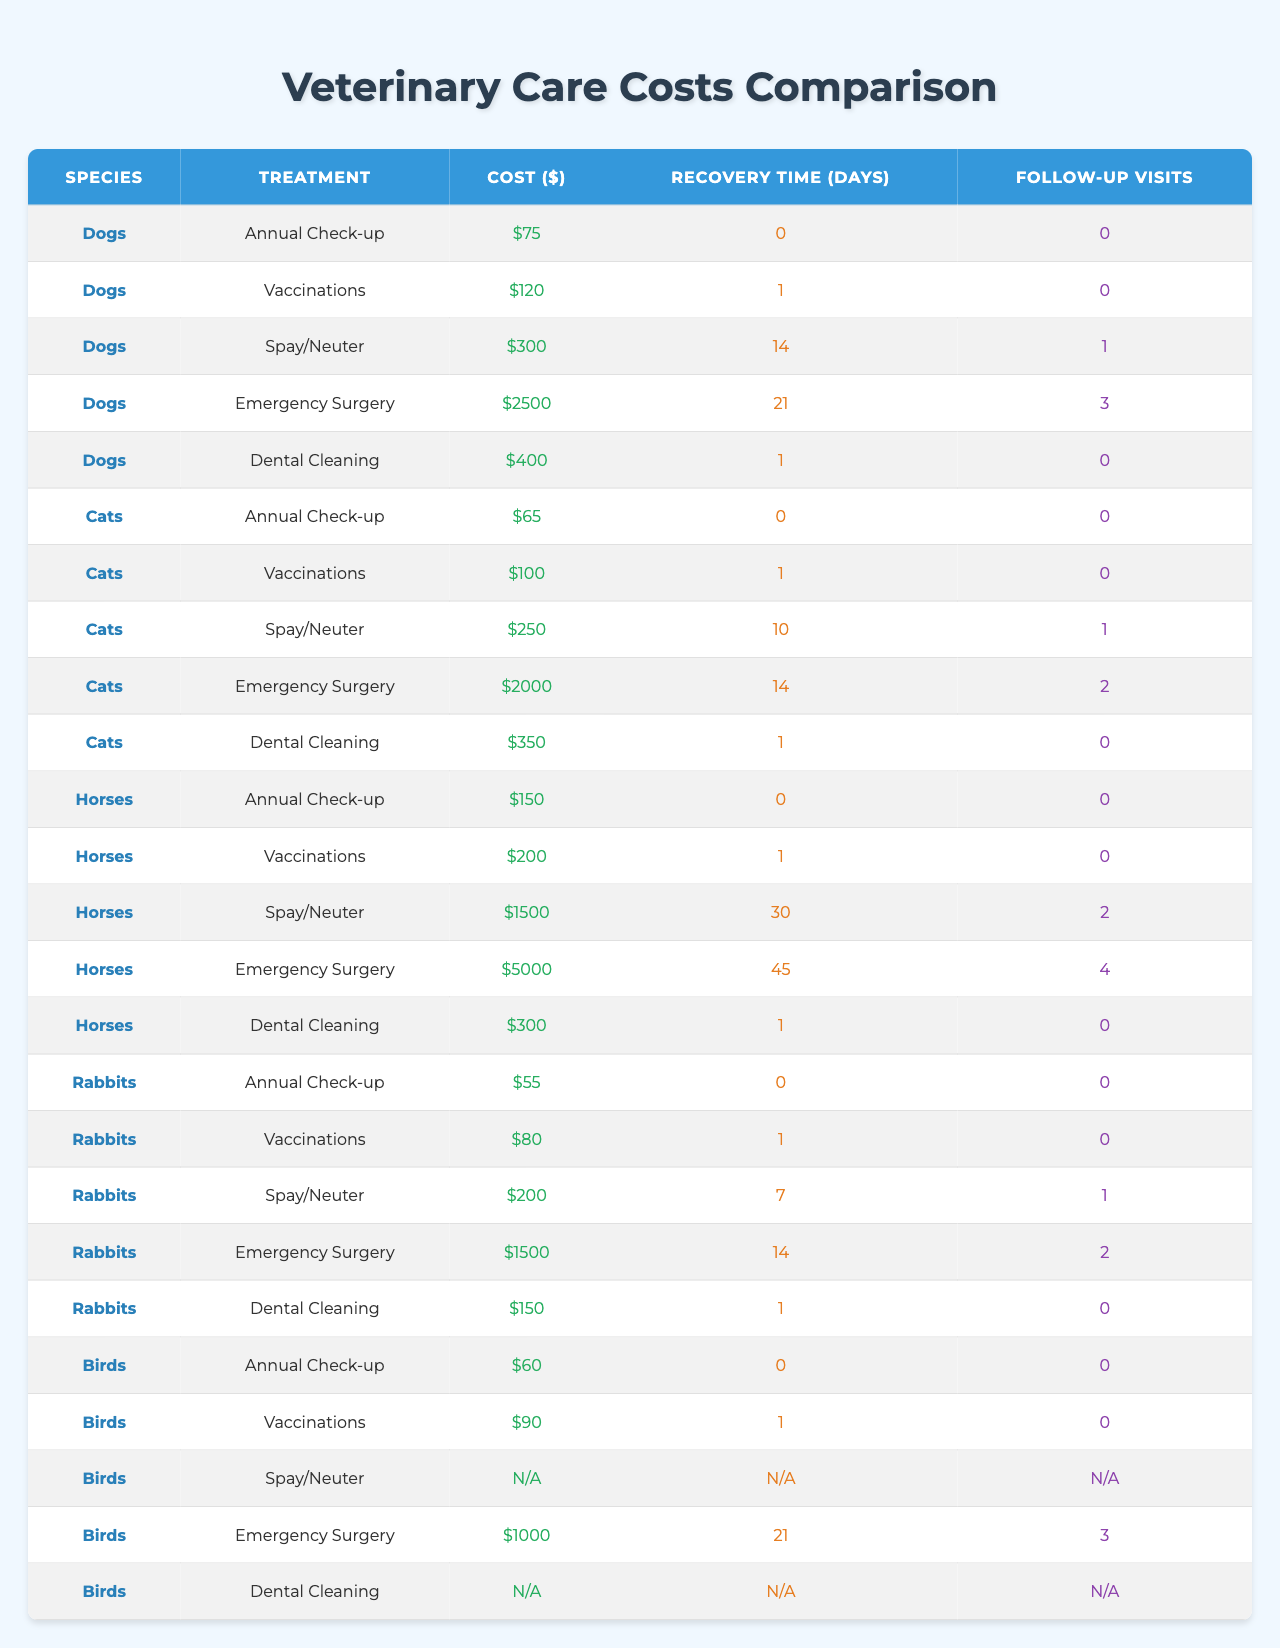What is the cost of an Annual Check-up for dogs? The table lists the cost of an Annual Check-up for dogs as $75 under the "Cost ($)" column.
Answer: $75 What treatment for cats has the highest cost? By examining the "Cost ($)" column for cats, the highest cost is for Spay/Neuter, which is $250.
Answer: Spay/Neuter Is the cost of Emergency Surgery for horses higher than for dogs? The cost for Emergency Surgery for horses is $5000, while for dogs, it is $2500. Since $5000 is greater than $2500, the statement is true.
Answer: Yes What is the average recovery time for dental cleaning for rabbits? The table indicates that the average recovery time for dental cleaning for rabbits is 1 day.
Answer: 1 How much more does Emergency Surgery cost for horses compared to cats? The cost for Emergency Surgery for horses is $5000 and for cats is $2000. The difference is calculated as $5000 - $2000 = $3000.
Answer: $3000 For which species is there no cost listed for Spay/Neuter? The cost for Spay/Neuter for birds is listed as null in the table, meaning that there is no cost provided.
Answer: Birds What is the total cost of vaccinations for all species combined? The costs of vaccinations for dogs ($120), cats ($100), horses ($200), rabbits ($80), and birds ($90) are summed: $120 + $100 + $200 + $80 + $90 = $590.
Answer: $590 Which treatment requires the most follow-up visits for horses? The treatment requiring the most follow-up visits for horses is Emergency Surgery, which requires 4 follow-up visits as per the "Follow-up Visits" column.
Answer: Emergency Surgery How many total days of recovery are needed for a dog undergoing Spay/Neuter and Emergency Surgery? The recovery time for Spay/Neuter in dogs is 14 days and for Emergency Surgery is 21 days. Adding them gives: 14 + 21 = 35 days.
Answer: 35 days For which animal species is the cost for Dental Cleaning less than the cost for Vaccinations? For rabbits, the cost of Dental Cleaning is $150, whereas the cost of Vaccinations is $80. Since $150 is greater than $80, the only species meeting this criterion is rabbits when compared to dogs, cats and birds.
Answer: Rabbits 